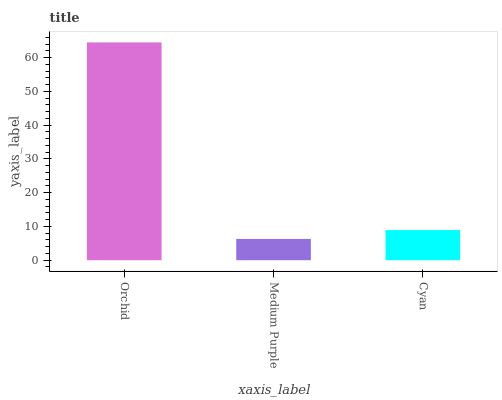Is Medium Purple the minimum?
Answer yes or no. Yes. Is Orchid the maximum?
Answer yes or no. Yes. Is Cyan the minimum?
Answer yes or no. No. Is Cyan the maximum?
Answer yes or no. No. Is Cyan greater than Medium Purple?
Answer yes or no. Yes. Is Medium Purple less than Cyan?
Answer yes or no. Yes. Is Medium Purple greater than Cyan?
Answer yes or no. No. Is Cyan less than Medium Purple?
Answer yes or no. No. Is Cyan the high median?
Answer yes or no. Yes. Is Cyan the low median?
Answer yes or no. Yes. Is Orchid the high median?
Answer yes or no. No. Is Medium Purple the low median?
Answer yes or no. No. 